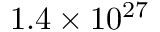<formula> <loc_0><loc_0><loc_500><loc_500>1 . 4 \times 1 0 ^ { 2 7 }</formula> 